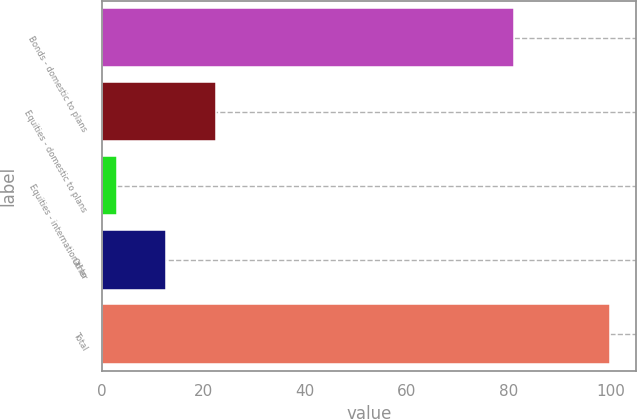Convert chart to OTSL. <chart><loc_0><loc_0><loc_500><loc_500><bar_chart><fcel>Bonds - domestic to plans<fcel>Equities - domestic to plans<fcel>Equities - international to<fcel>Other<fcel>Total<nl><fcel>81<fcel>22.4<fcel>3<fcel>12.7<fcel>100<nl></chart> 